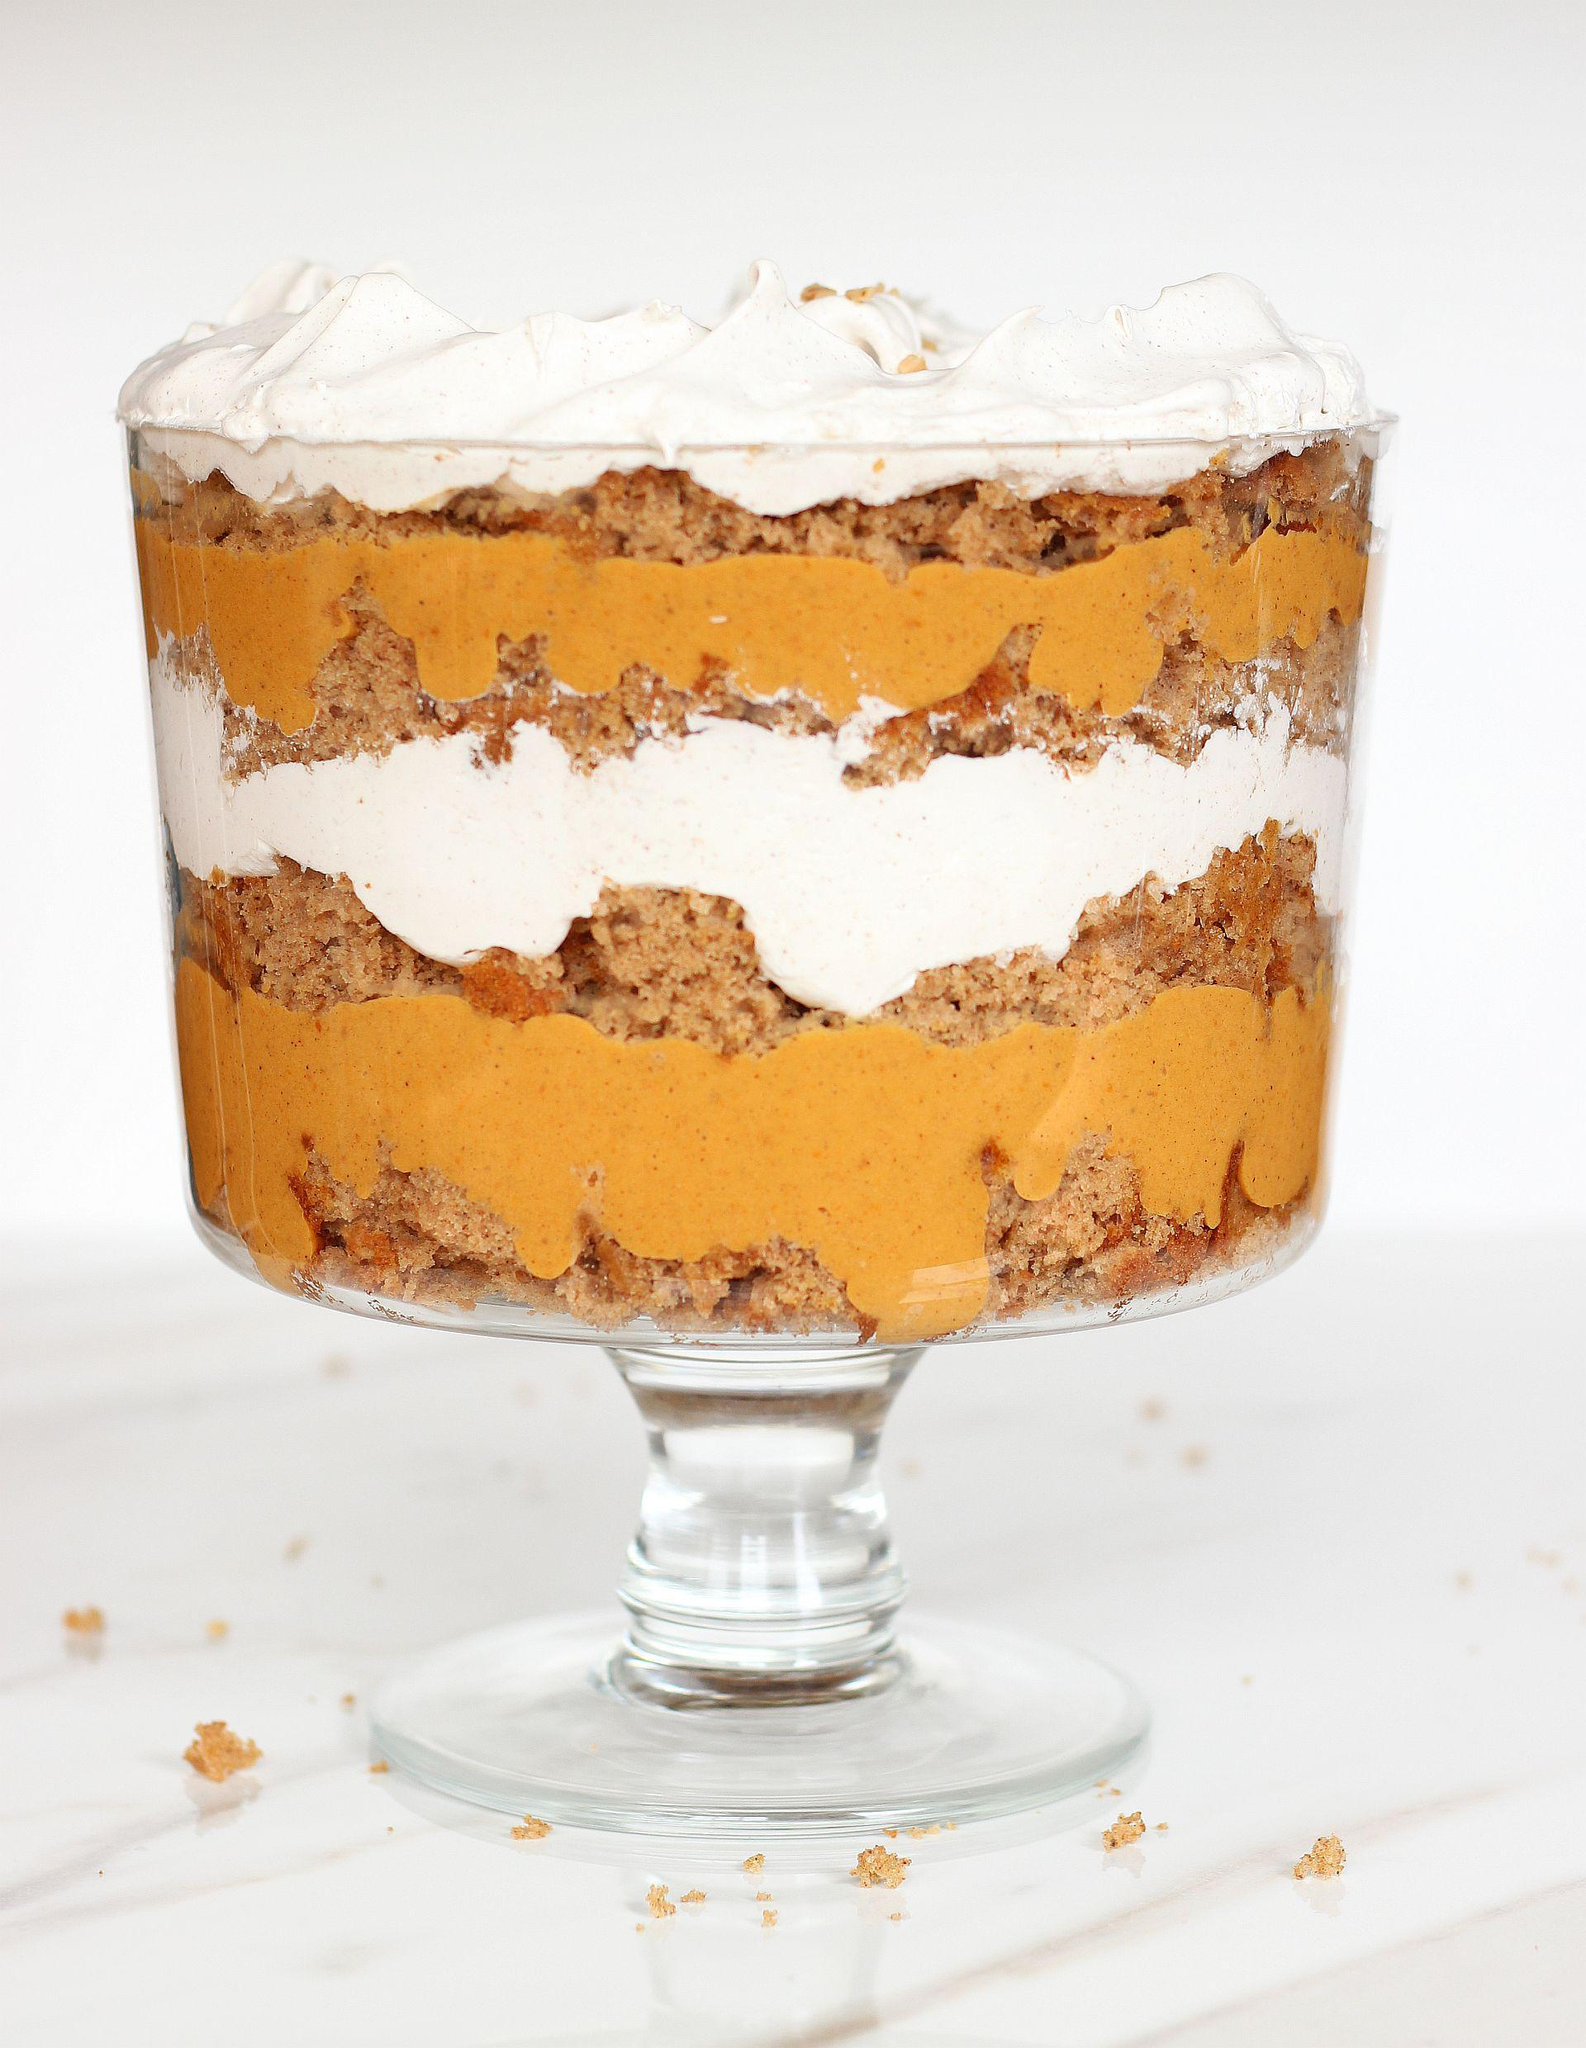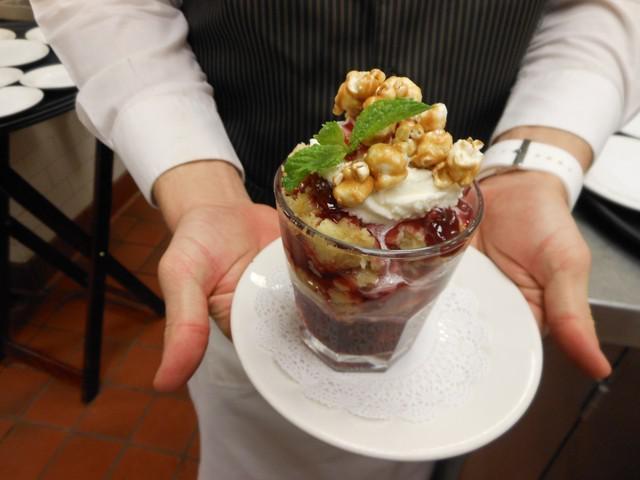The first image is the image on the left, the second image is the image on the right. Evaluate the accuracy of this statement regarding the images: "The left image shows one layered dessert served in a footed glass.". Is it true? Answer yes or no. Yes. The first image is the image on the left, the second image is the image on the right. Analyze the images presented: Is the assertion "One large fancy dessert and three servings of a different dessert are shown." valid? Answer yes or no. No. 